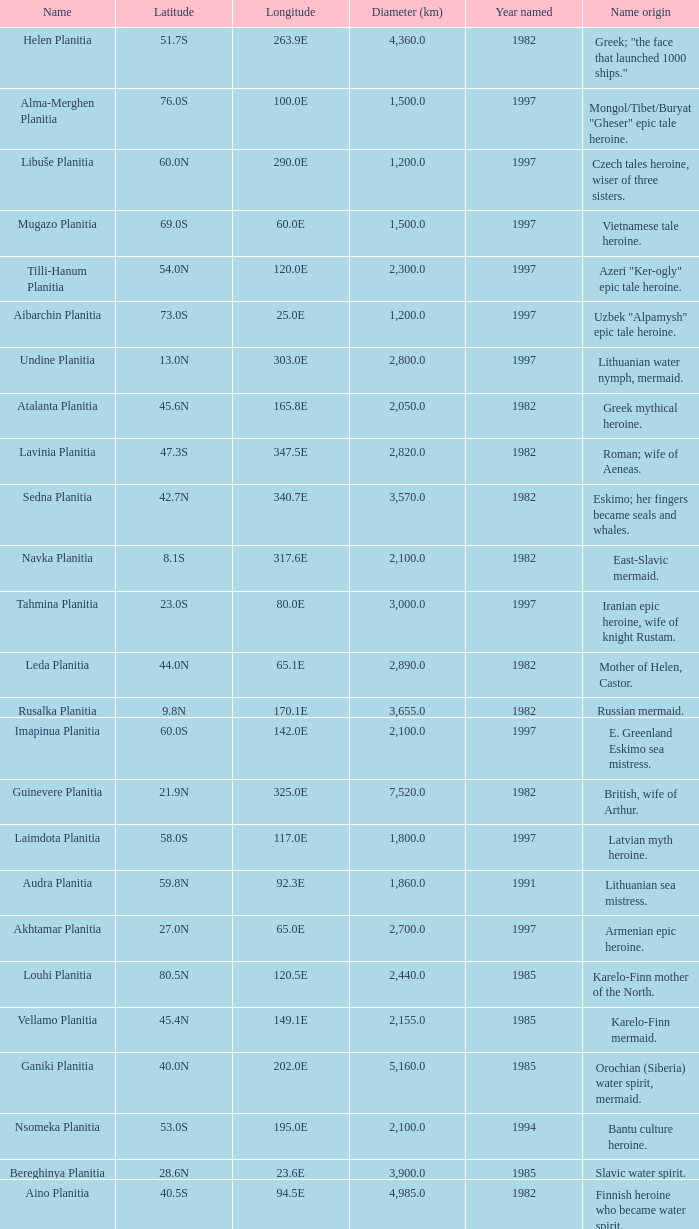What is the diameter (km) of feature of latitude 40.5s 4985.0. 